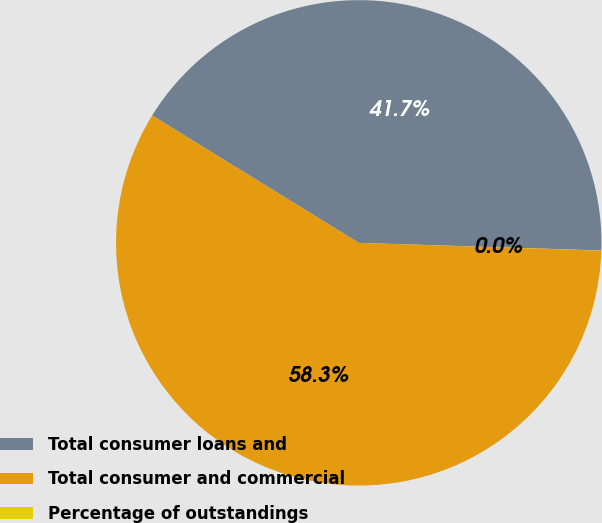Convert chart to OTSL. <chart><loc_0><loc_0><loc_500><loc_500><pie_chart><fcel>Total consumer loans and<fcel>Total consumer and commercial<fcel>Percentage of outstandings<nl><fcel>41.71%<fcel>58.28%<fcel>0.01%<nl></chart> 